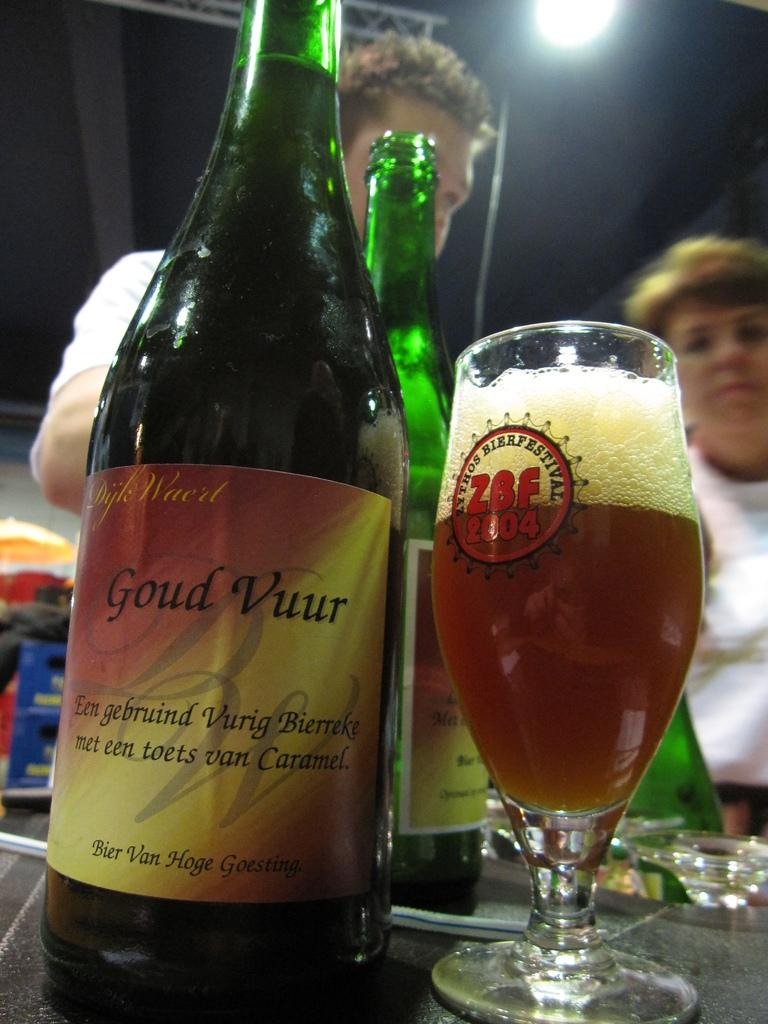<image>
Summarize the visual content of the image. Bottle of Goud Vuur next to a cup of beer. 